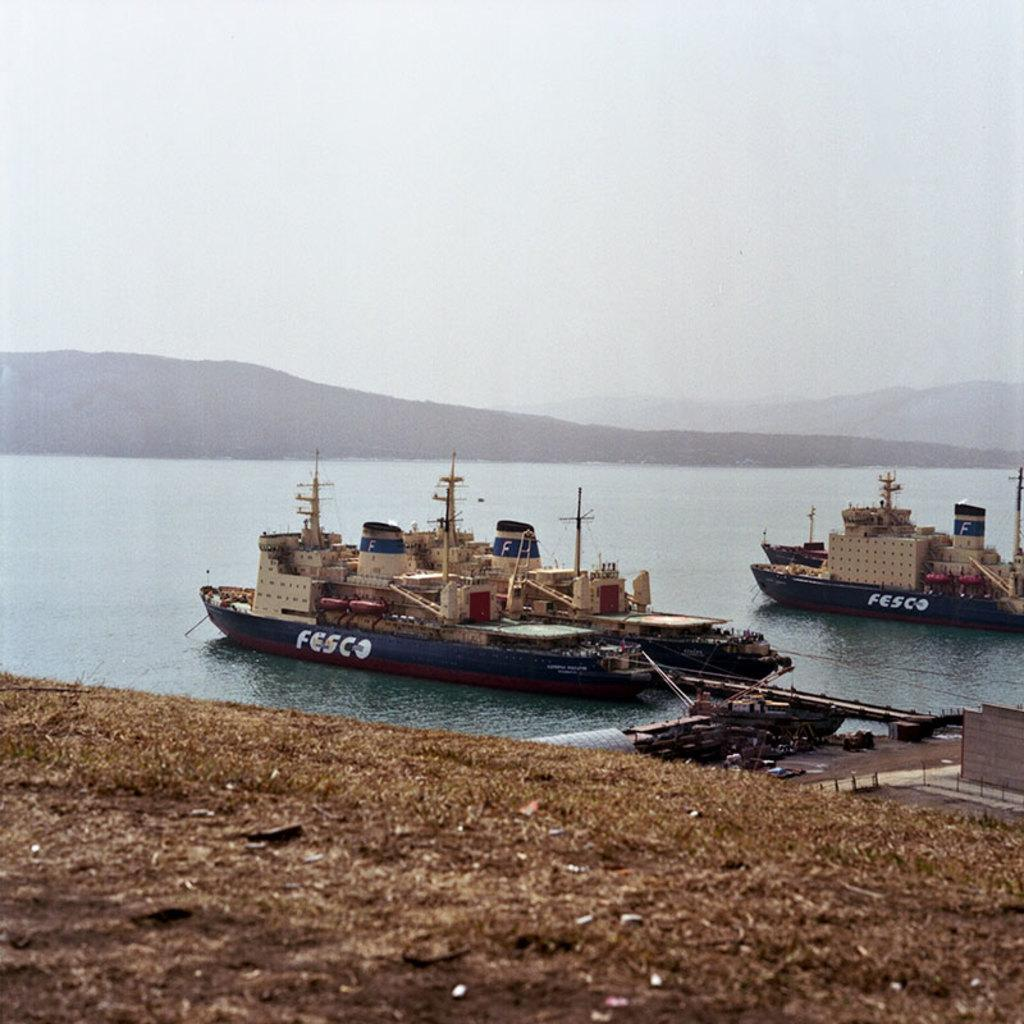What type of vehicles can be seen on the surface of the river in the image? There are ships on the surface of the river in the image. What can be seen in the background of the image? There is a hill visible in the background. What is visible at the top of the image? The sky is visible at the top of the image. What is visible at the bottom of the image? The ground is visible at the bottom of the image. Can you see a dog playing with a ball on the hill in the image? There is no dog or ball present in the image; it features ships on the river and a hill in the background. 